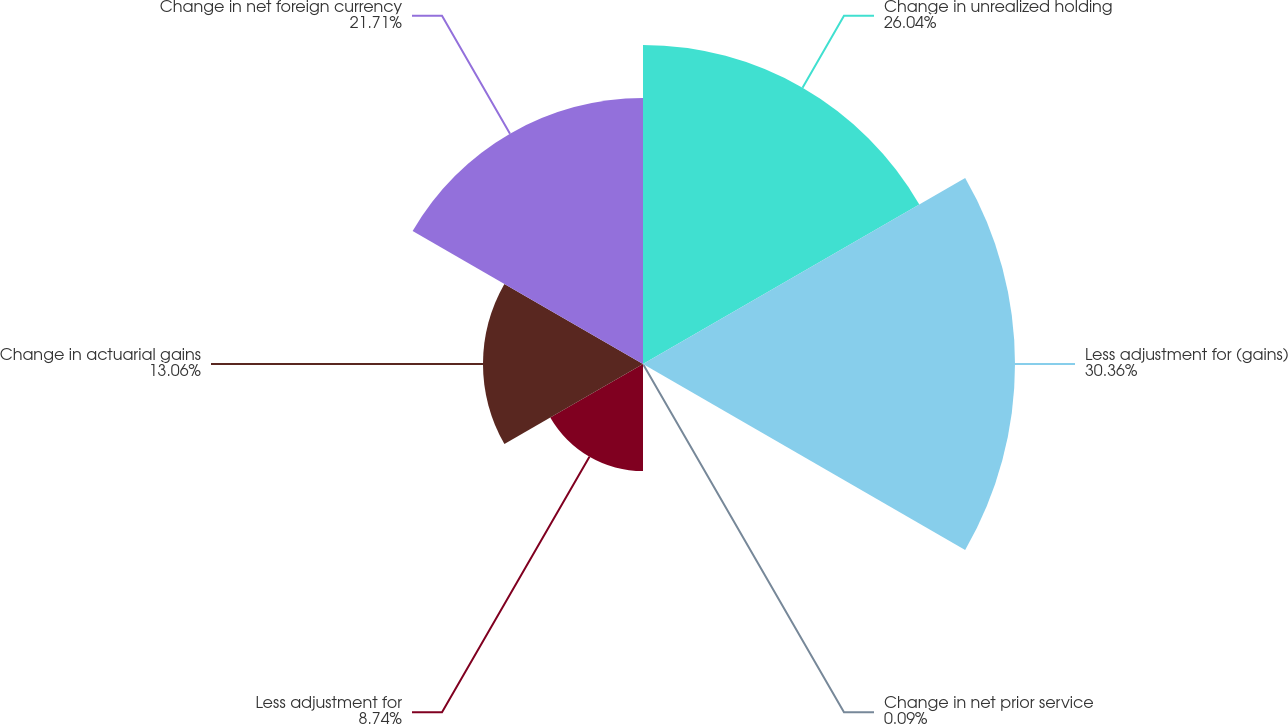Convert chart. <chart><loc_0><loc_0><loc_500><loc_500><pie_chart><fcel>Change in unrealized holding<fcel>Less adjustment for (gains)<fcel>Change in net prior service<fcel>Less adjustment for<fcel>Change in actuarial gains<fcel>Change in net foreign currency<nl><fcel>26.04%<fcel>30.36%<fcel>0.09%<fcel>8.74%<fcel>13.06%<fcel>21.71%<nl></chart> 